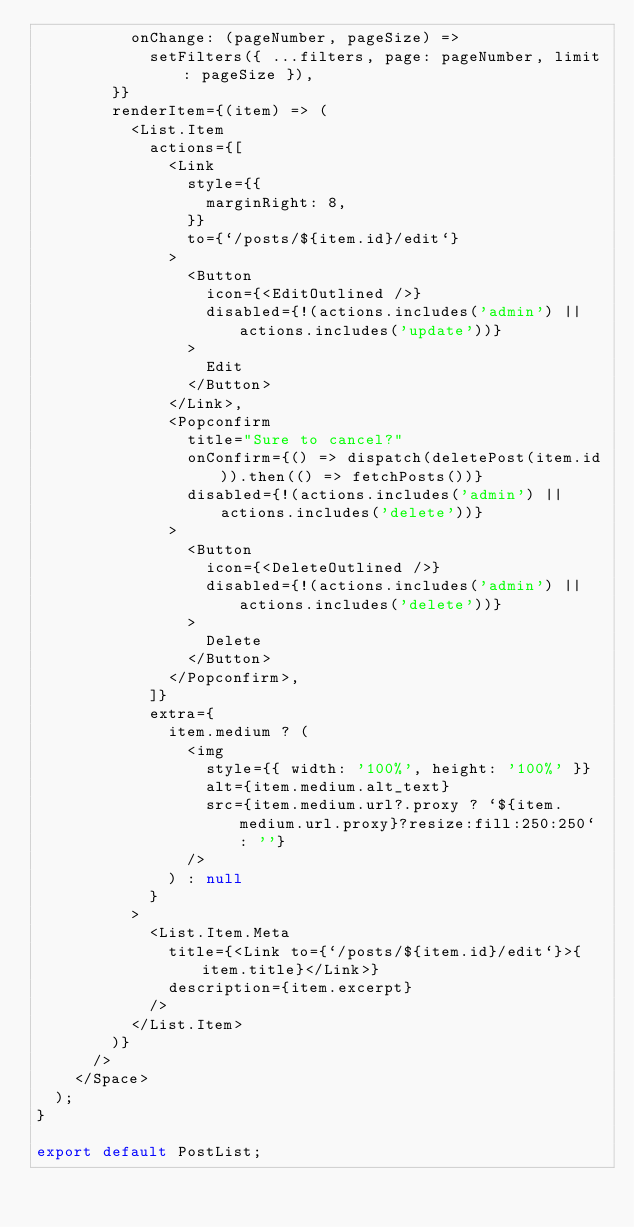<code> <loc_0><loc_0><loc_500><loc_500><_JavaScript_>          onChange: (pageNumber, pageSize) =>
            setFilters({ ...filters, page: pageNumber, limit: pageSize }),
        }}
        renderItem={(item) => (
          <List.Item
            actions={[
              <Link
                style={{
                  marginRight: 8,
                }}
                to={`/posts/${item.id}/edit`}
              >
                <Button
                  icon={<EditOutlined />}
                  disabled={!(actions.includes('admin') || actions.includes('update'))}
                >
                  Edit
                </Button>
              </Link>,
              <Popconfirm
                title="Sure to cancel?"
                onConfirm={() => dispatch(deletePost(item.id)).then(() => fetchPosts())}
                disabled={!(actions.includes('admin') || actions.includes('delete'))}
              >
                <Button
                  icon={<DeleteOutlined />}
                  disabled={!(actions.includes('admin') || actions.includes('delete'))}
                >
                  Delete
                </Button>
              </Popconfirm>,
            ]}
            extra={
              item.medium ? (
                <img
                  style={{ width: '100%', height: '100%' }}
                  alt={item.medium.alt_text}
                  src={item.medium.url?.proxy ? `${item.medium.url.proxy}?resize:fill:250:250` : ''}
                />
              ) : null
            }
          >
            <List.Item.Meta
              title={<Link to={`/posts/${item.id}/edit`}>{item.title}</Link>}
              description={item.excerpt}
            />
          </List.Item>
        )}
      />
    </Space>
  );
}

export default PostList;
</code> 